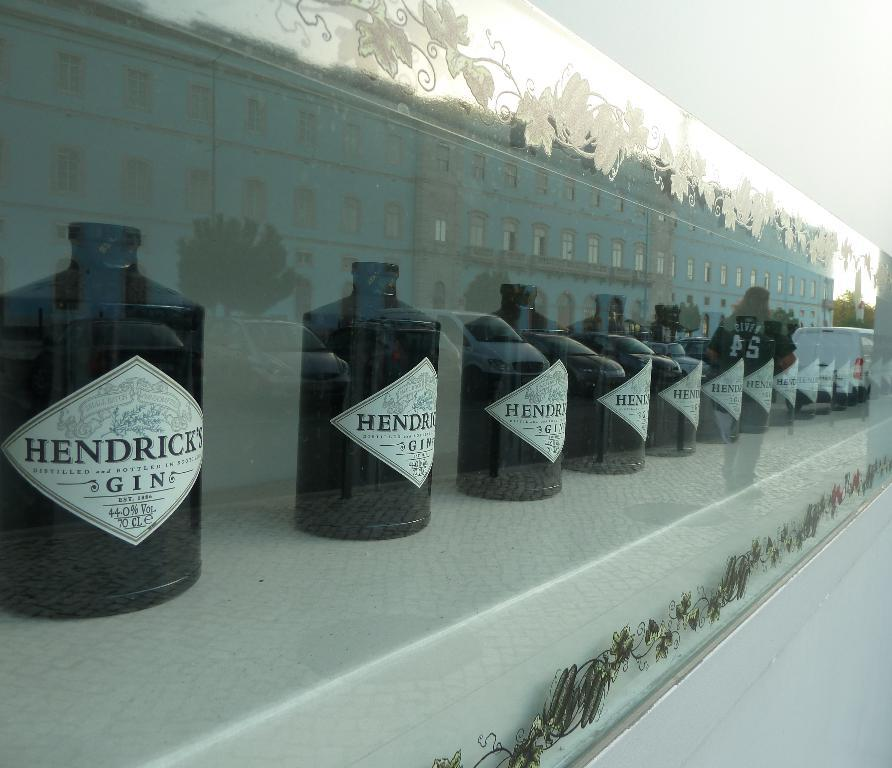<image>
Offer a succinct explanation of the picture presented. many jugs of Hendrick's Gin lined up on a store front 